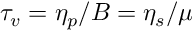<formula> <loc_0><loc_0><loc_500><loc_500>\tau _ { v } = \eta _ { p } / B = \eta _ { s } / \mu</formula> 